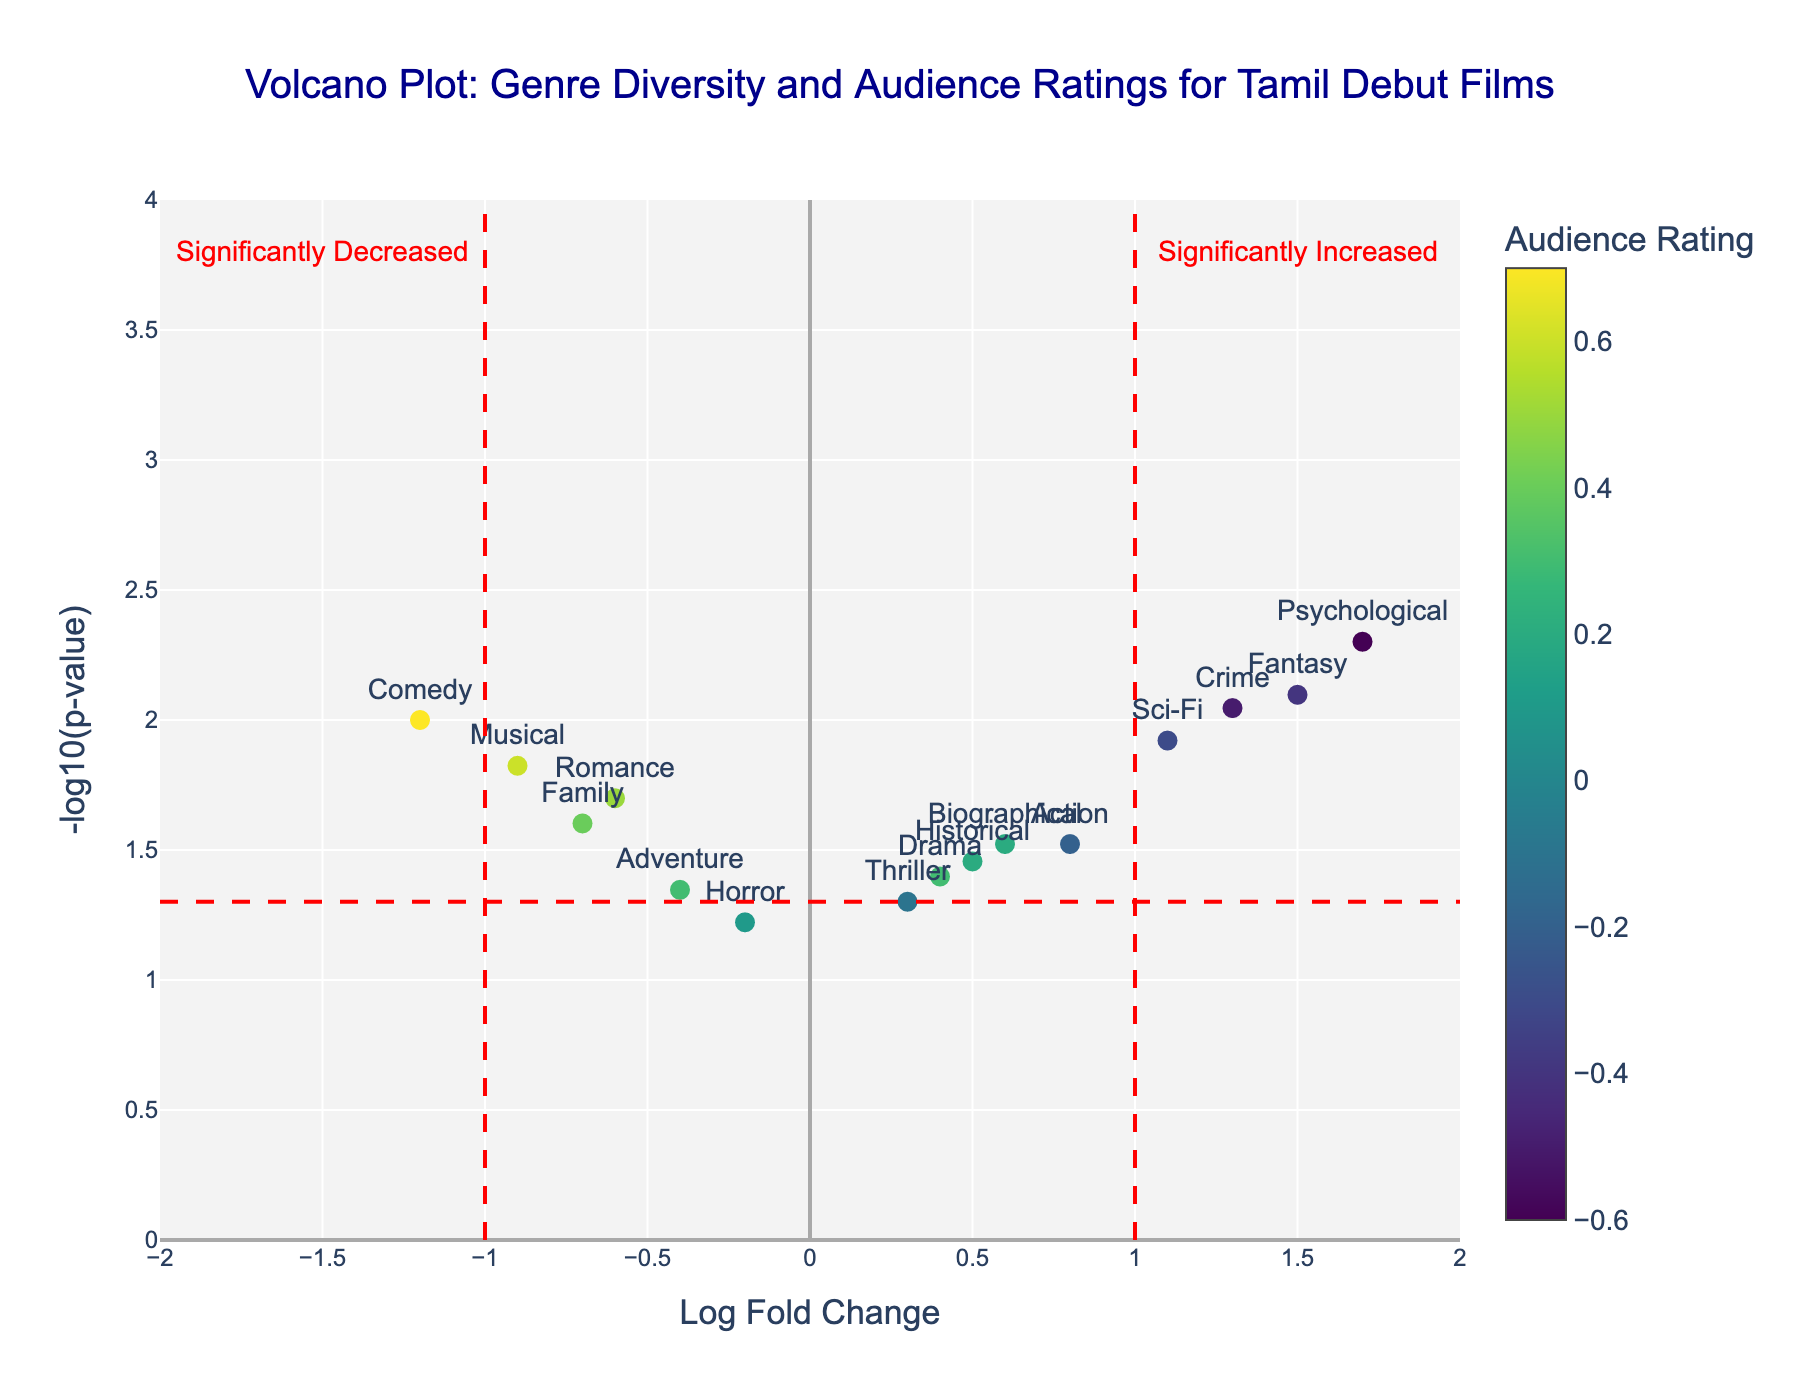What genre has the highest -log10(p-value)? To determine the genre with the highest -log10(p-value), check the vertical axis and look for the point with the highest value. The highest value is 2.7, which corresponds to the genre "Psychological".
Answer: Psychological What genre shows the most significant increase on the Log Fold Change axis? Locate the farthest point to the right on the x-axis, representing the greatest increase in Log Fold Change. This point is at 1.7, corresponding to the genre "Psychological".
Answer: Psychological Which genre has the lowest audience rating? Check the color scale on the vertical color bar to determine which genre has the darkest color, indicating the lowest audience rating. The darkest point corresponds to "Psychological" with an audience rating of -0.6.
Answer: Psychological How many genres have a -log10(p-value) greater than 1.3? Count the number of data points above the 1.3 mark on the y-axis. These points are: Comedy, Musical, Fantasy, Sci-Fi, Crime, and Psychological, making a total of six data points.
Answer: 6 What is the Log Fold Change for the genre Comedy? Locate the "Comedy" label on the plot and read its corresponding value on the x-axis. The Log Fold Change for Comedy is approximately -1.2.
Answer: -1.2 Compare the Log Fold Change between Romance and Action. Which one is higher? Identify the Log Fold Change values for Romance and Action from the plot. Romance is at -0.6, and Action is at 0.8. Therefore, Action has a higher Log Fold Change.
Answer: Action Which genre appears to be the most statistically significant given its p-value? The most statistically significant genre is indicated by the highest -log10(p-value), which is for "Psychological" with a -log10(p-value) of 2.7.
Answer: Psychological What genres fall under the category of having a significantly decreased Log Fold Change based on the vertical red lines? Any data points to the left of x = -1 are considered to have significantly decreased Log Fold Change. These points are "Psychological".
Answer: Psychological 